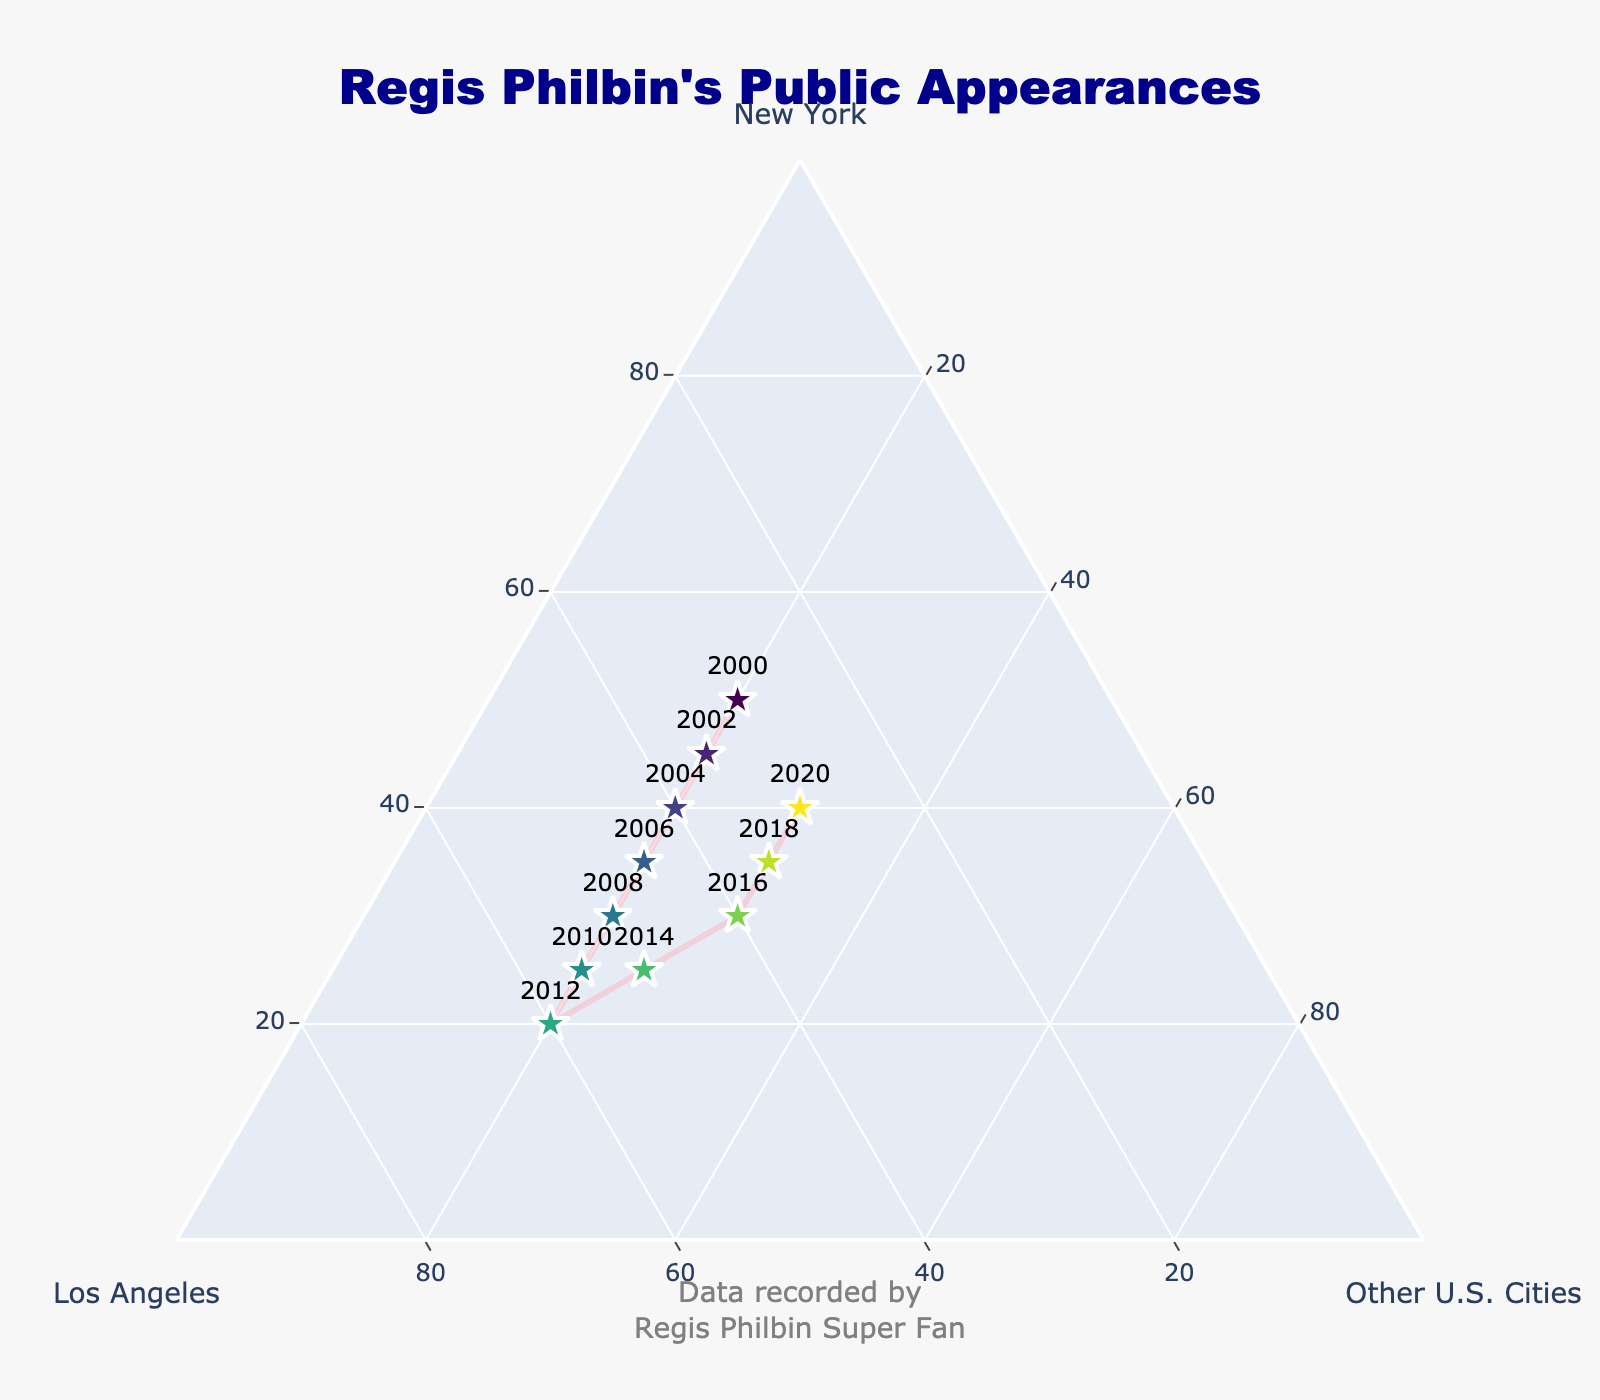what is the title of the plot? The title of the plot is located at the top of the figure in large, bold text.
Answer: Regis Philbin's Public Appearances how many data points are represented in the figure? Each data point represents a specific year from 2000 to 2020. To determine the number of data points, count the number of different years.
Answer: 11 what city saw the highest percentage of Regis's appearances in 2010? To find this, look at the data point labeled "2010". The city with the highest percentage will be the one that has the value furthest from the base.
Answer: Los Angeles which city had a consistent percentage of Regis's appearances over the years? From the data points, the "Other U.S. Cities" category consistently shows a 20% or 25% presence throughout the years.
Answer: Other U.S. Cities did Regis's appearances in new york increase or decrease from 2000 to 2012? Look at the data points for "2000" and "2012". The percentage for New York decreases over this time.
Answer: Decrease what's the difference in the number of appearances in new york between 2004 and 2016? Check the data points for "2004" and "2016". New York had 40% in 2004 and 30% in 2016, so the difference is 40 - 30.
Answer: 10% in which year did Regis's appearances in los angeles equal those in New York? To determine this, identify the data point where the values for Los Angeles and New York are equal. This occurs in the year "2004".
Answer: 2004 which year shows the highest combined percentage for "other U.S. cities"? "Other U.S. Cities" percentage is consistent but increased slightly in 2014 and 2016. The highest occurs in the year "2016" with 30%.
Answer: 2016 